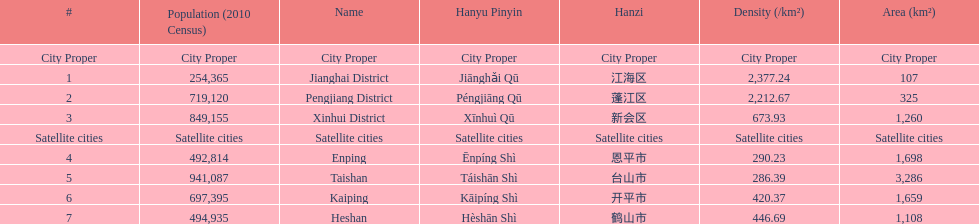What is the most populated district? Taishan. 